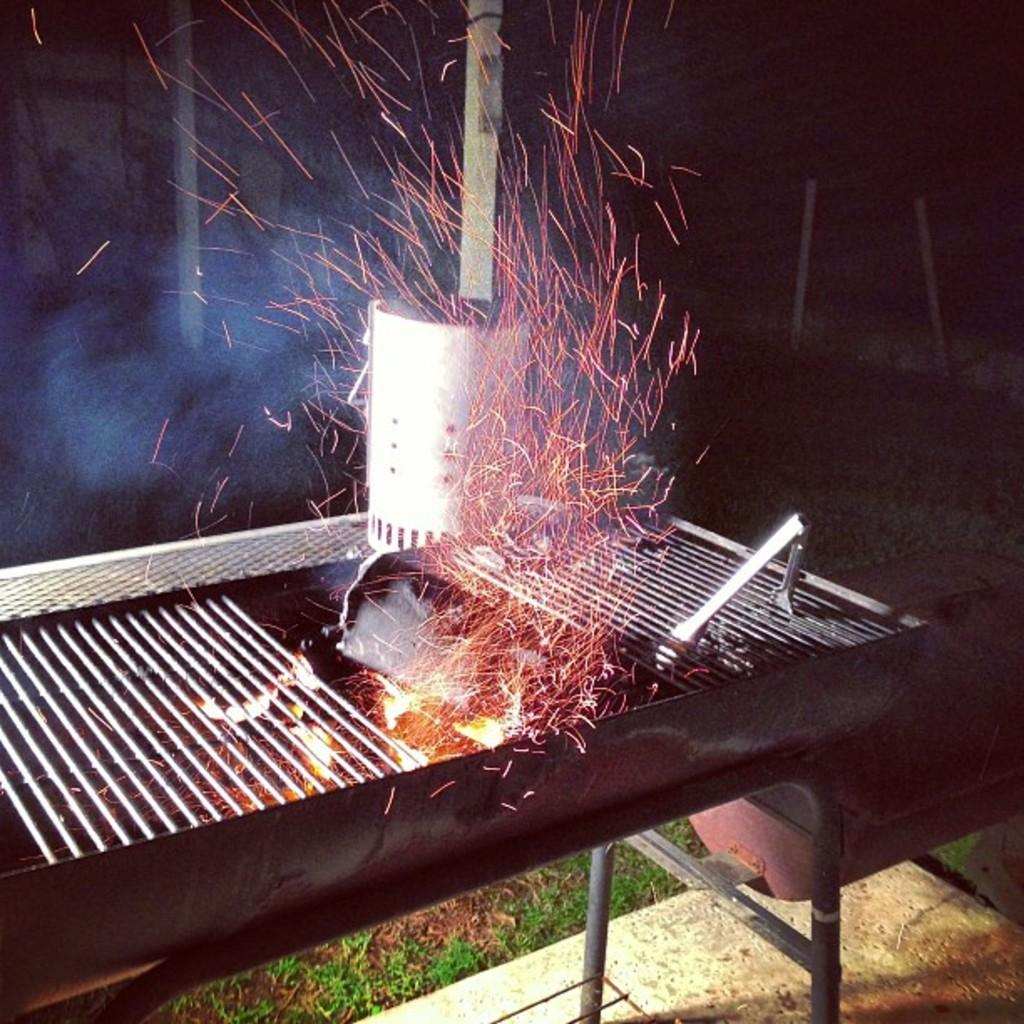What is the main object in the image? There is a barbecue in the image. What is happening with the barbecue? Flames are visible in the image, indicating that something is being cooked or heated. What tool is present in the image for handling food? Tongs are present in the image. What type of surface is visible at the bottom of the image? Grass is visible at the bottom of the image. What are the rods at the bottom of the image used for? The rods at the bottom of the image are likely used to support the barbecue. What is the background of the image like? The background of the image is dark, and there are poles visible. What object is present in the background of the image? There is an object in the background of the image, but its specific nature is not clear from the provided facts. What type of bread can be seen on the chin of the person in the image? There is no person present in the image, and therefore no chin or bread can be observed. 